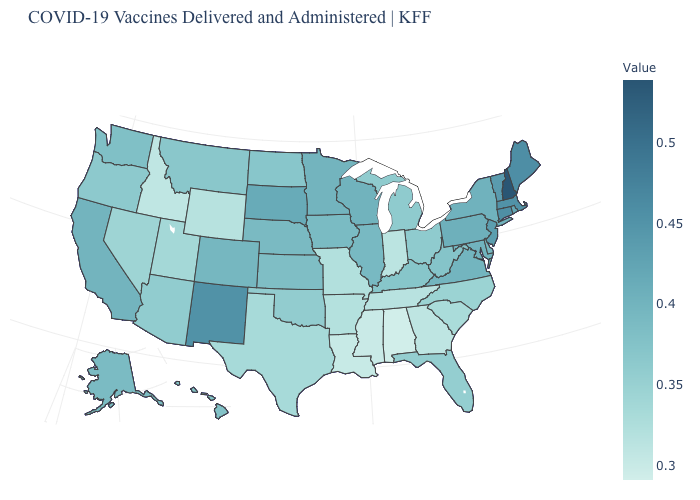Does Connecticut have the highest value in the Northeast?
Write a very short answer. No. Does New Hampshire have a lower value than New York?
Be succinct. No. Does Virginia have the lowest value in the USA?
Quick response, please. No. 